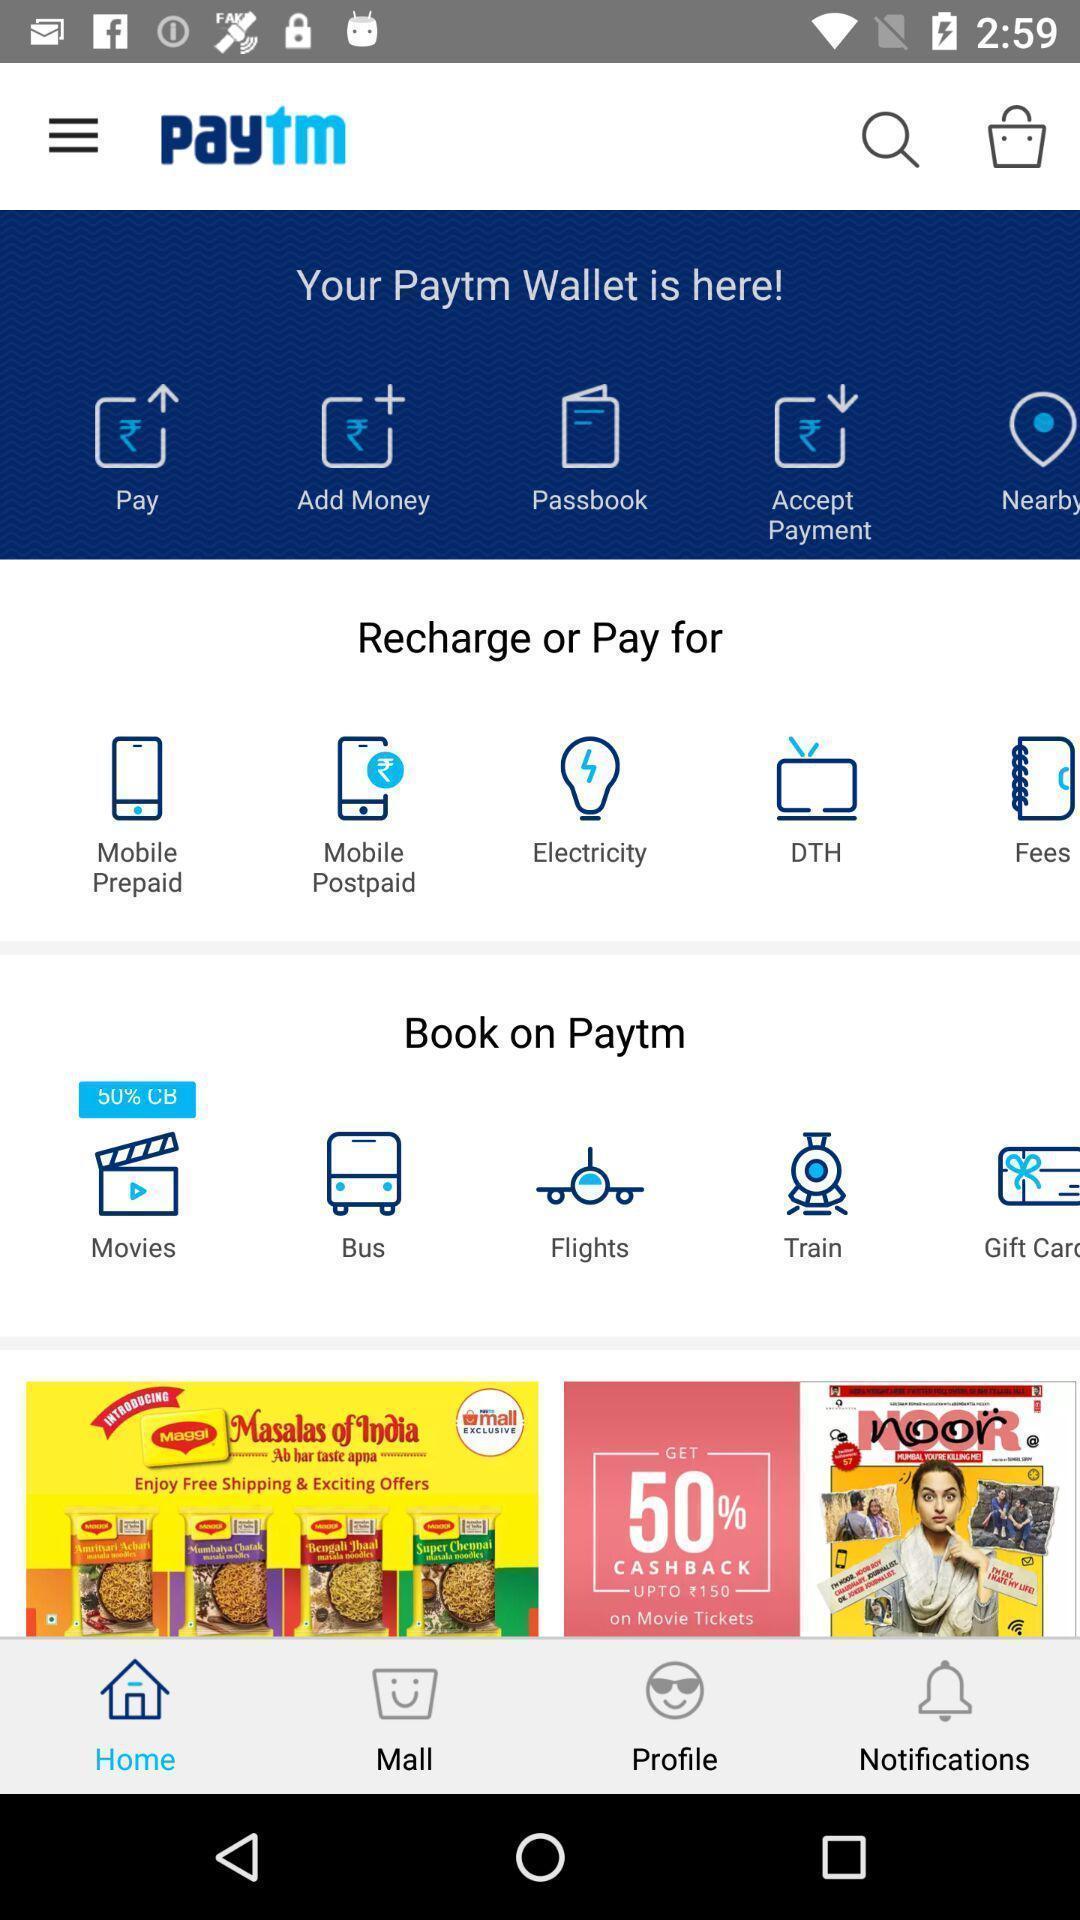Describe the visual elements of this screenshot. Page displaying the menu of a financial app. 